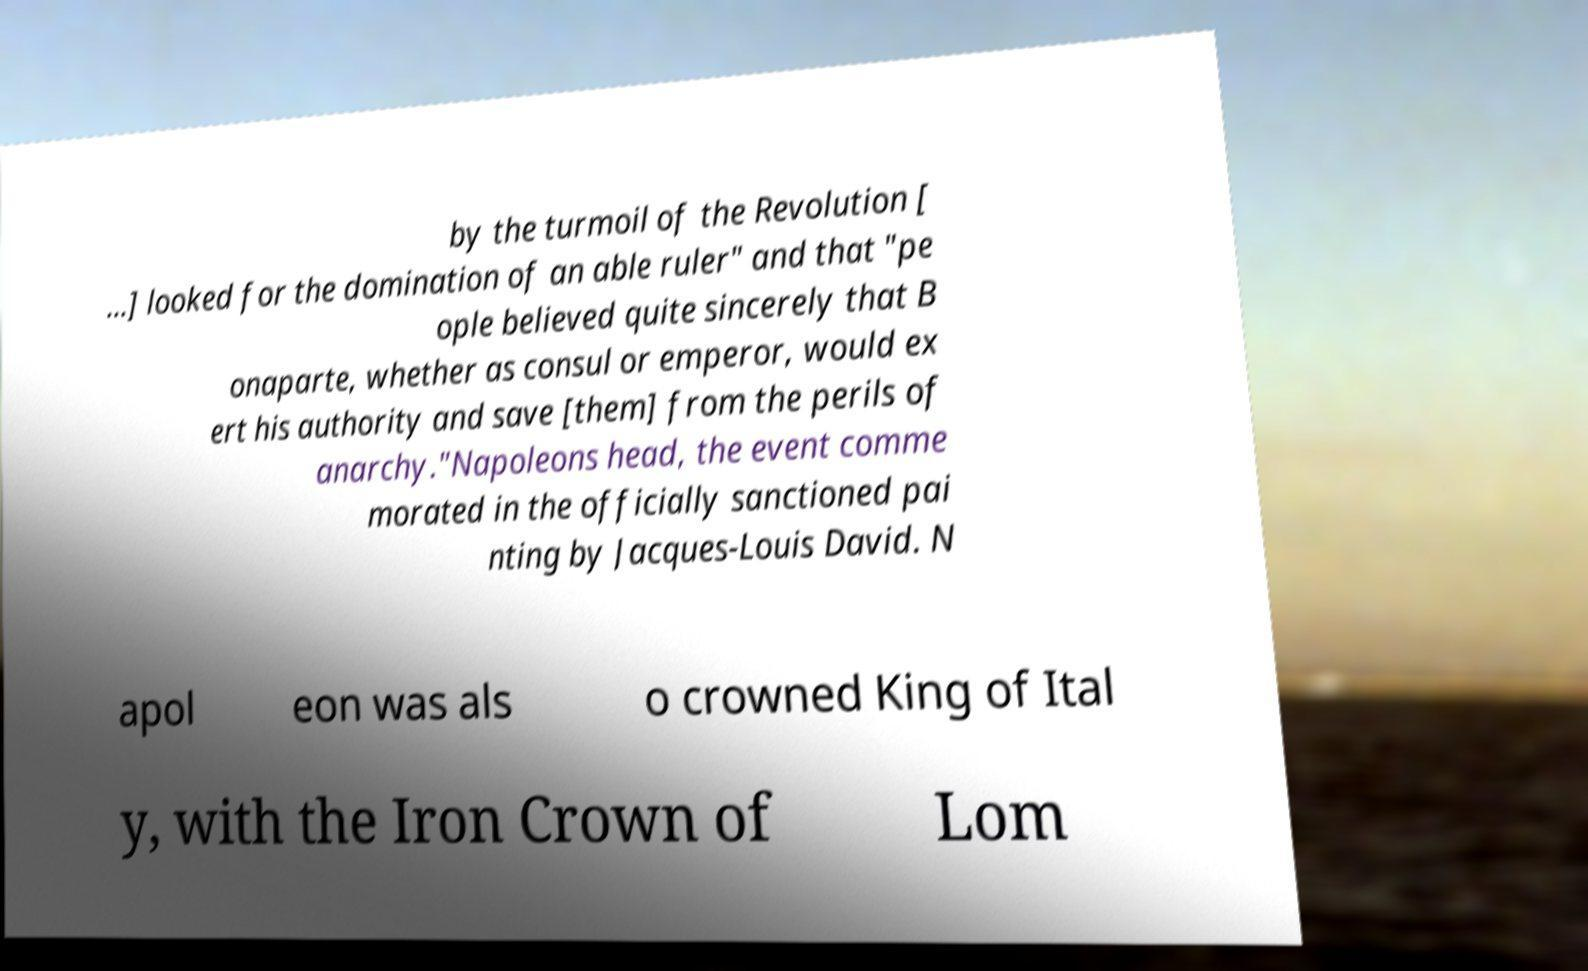Can you read and provide the text displayed in the image?This photo seems to have some interesting text. Can you extract and type it out for me? by the turmoil of the Revolution [ …] looked for the domination of an able ruler" and that "pe ople believed quite sincerely that B onaparte, whether as consul or emperor, would ex ert his authority and save [them] from the perils of anarchy."Napoleons head, the event comme morated in the officially sanctioned pai nting by Jacques-Louis David. N apol eon was als o crowned King of Ital y, with the Iron Crown of Lom 